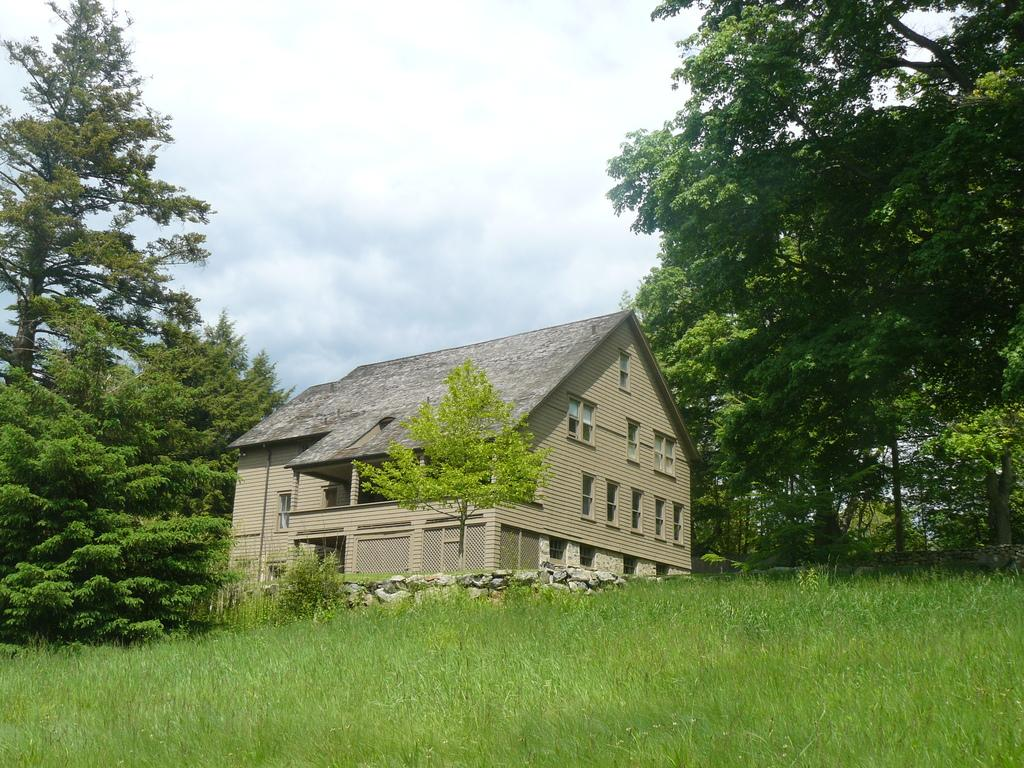What type of structure is in the image? There is a house in the image. What features can be seen on the house? The house has windows, pillars, and walls. What type of vegetation is present in the image? There are trees, plants, and grass in the image. What can be seen in the background of the image? The sky is visible in the background of the image. What type of reward is being offered to the person with the best haircut in the image? There is no mention of a reward or haircut in the image; it features a house with windows, pillars, and walls, surrounded by trees, plants, and grass, with the sky visible in the background. 